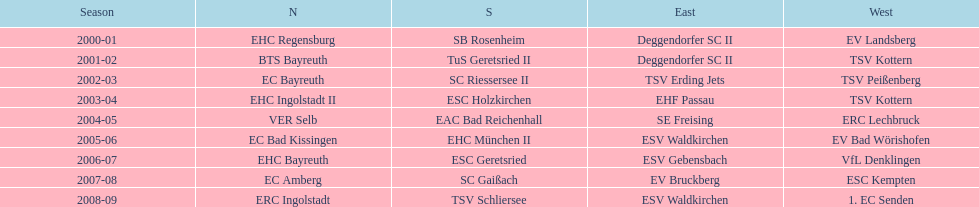What was the first club for the north in the 2000's? EHC Regensburg. 